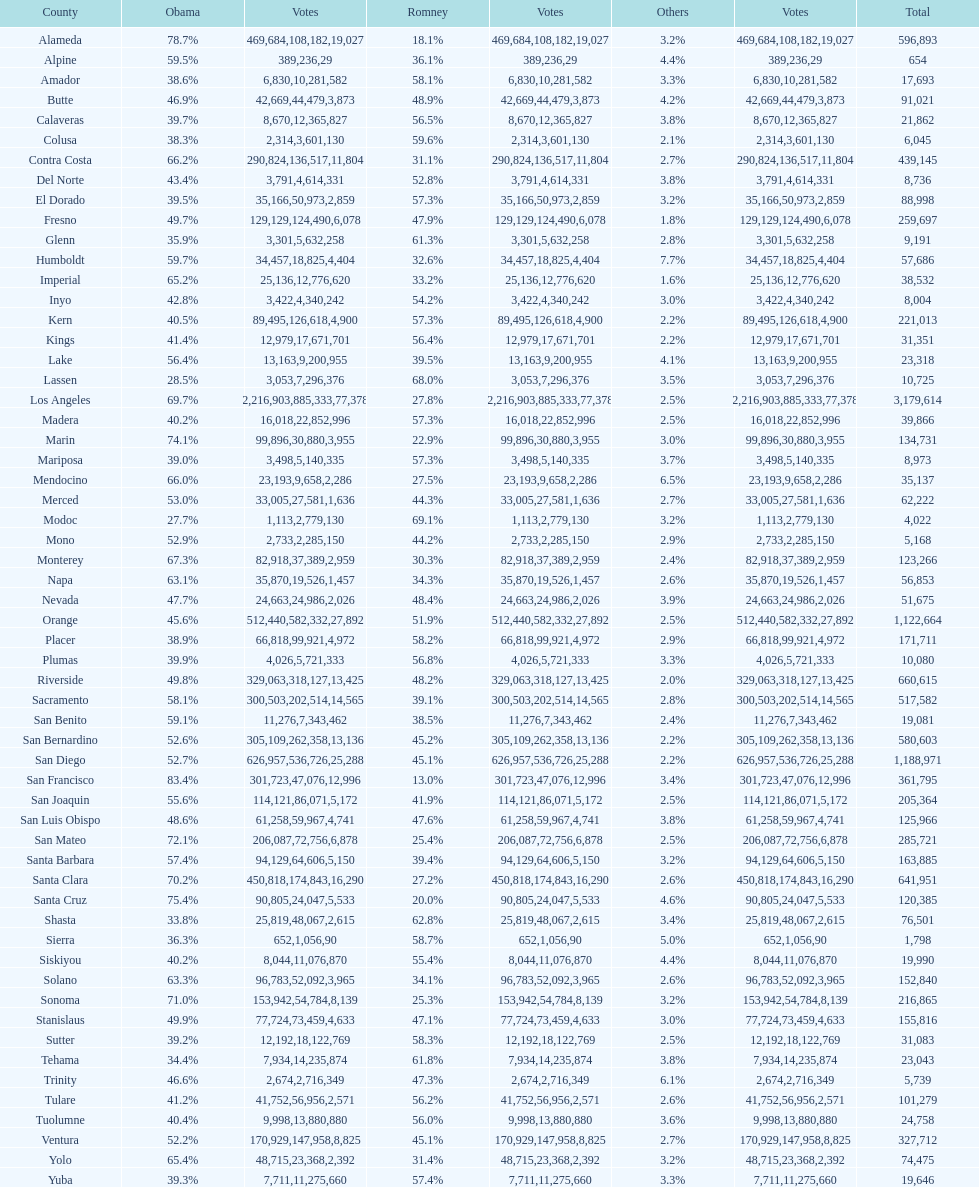Which county comes just prior to del norte on the list? Contra Costa. 